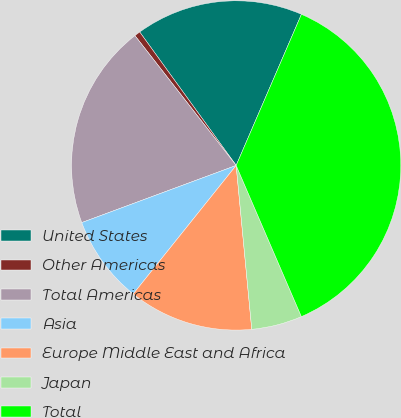<chart> <loc_0><loc_0><loc_500><loc_500><pie_chart><fcel>United States<fcel>Other Americas<fcel>Total Americas<fcel>Asia<fcel>Europe Middle East and Africa<fcel>Japan<fcel>Total<nl><fcel>16.45%<fcel>0.58%<fcel>20.1%<fcel>8.61%<fcel>12.26%<fcel>4.97%<fcel>37.03%<nl></chart> 